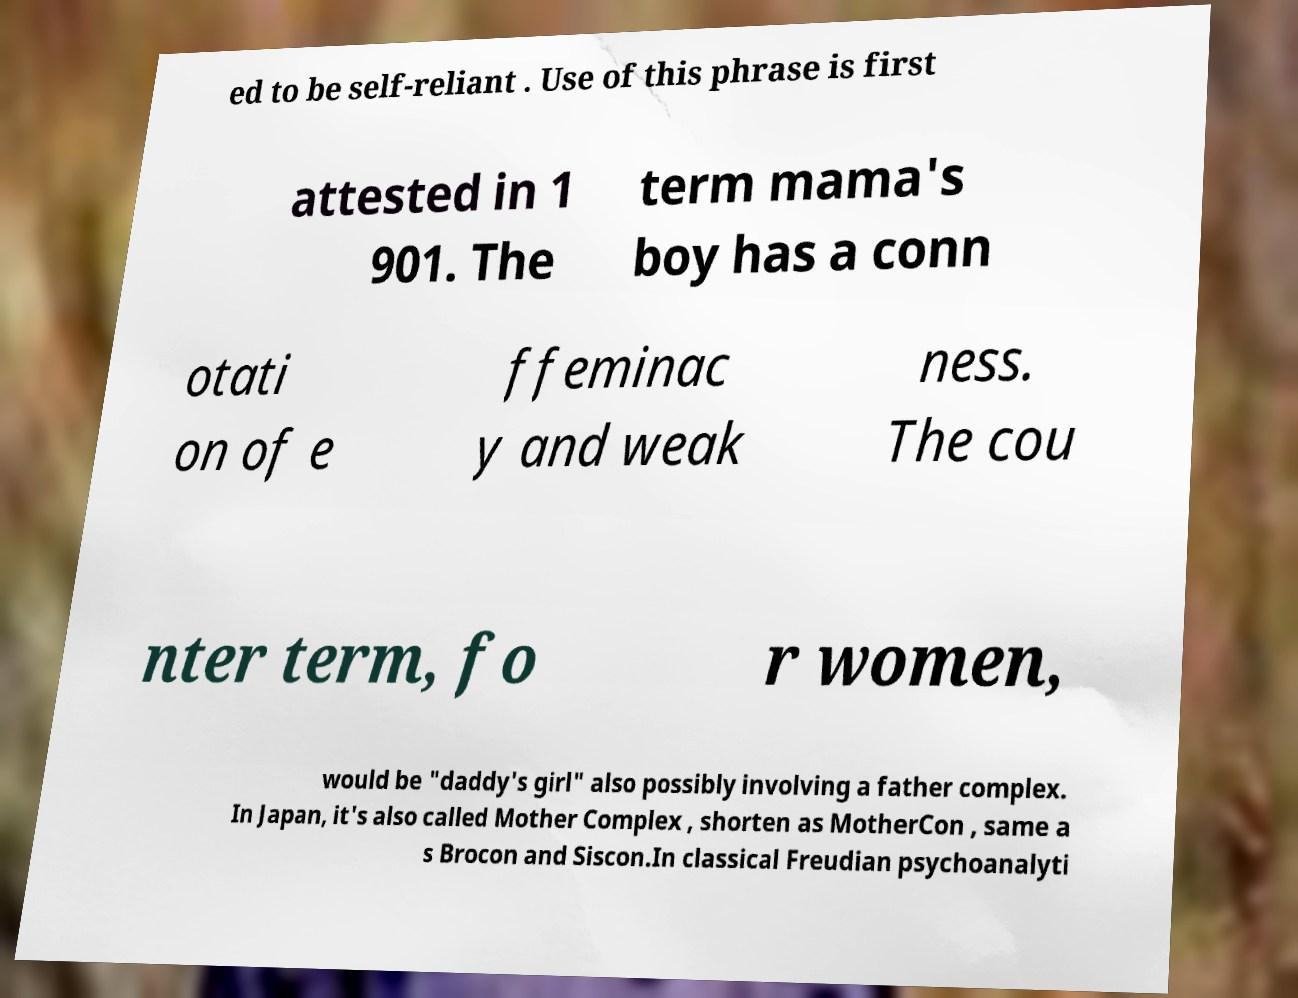Please identify and transcribe the text found in this image. ed to be self-reliant . Use of this phrase is first attested in 1 901. The term mama's boy has a conn otati on of e ffeminac y and weak ness. The cou nter term, fo r women, would be "daddy's girl" also possibly involving a father complex. In Japan, it's also called Mother Complex , shorten as MotherCon , same a s Brocon and Siscon.In classical Freudian psychoanalyti 